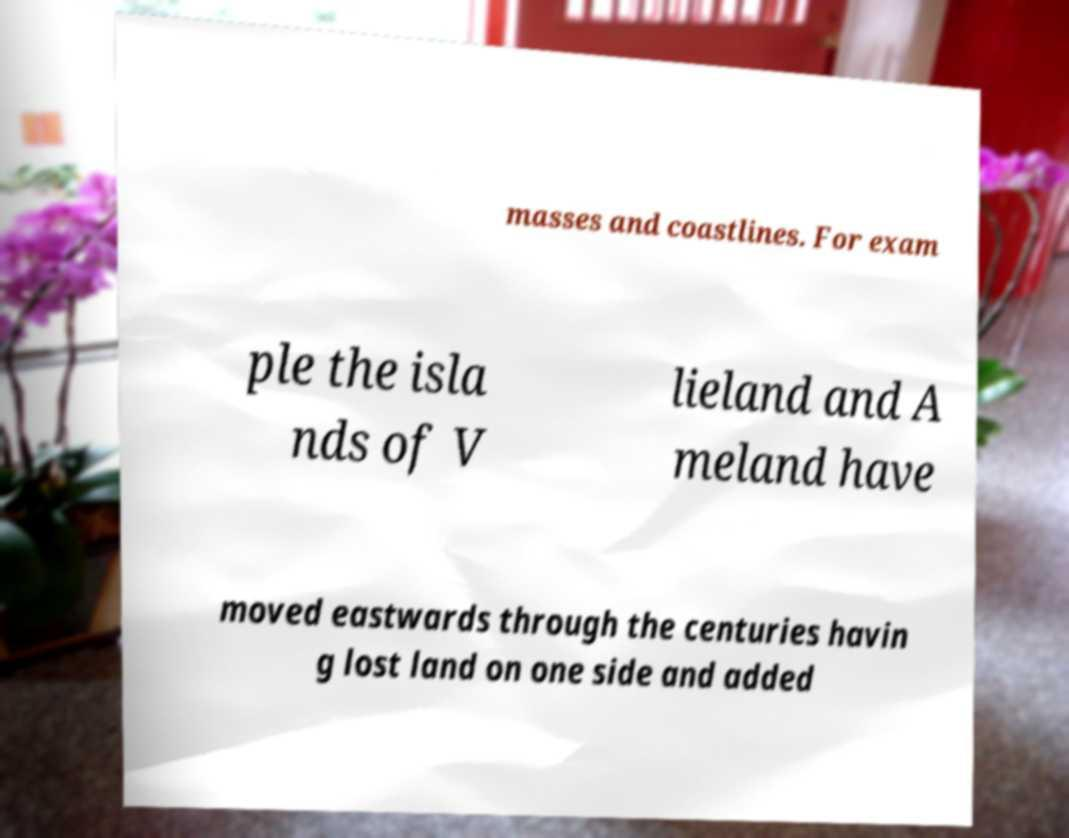Can you read and provide the text displayed in the image?This photo seems to have some interesting text. Can you extract and type it out for me? masses and coastlines. For exam ple the isla nds of V lieland and A meland have moved eastwards through the centuries havin g lost land on one side and added 